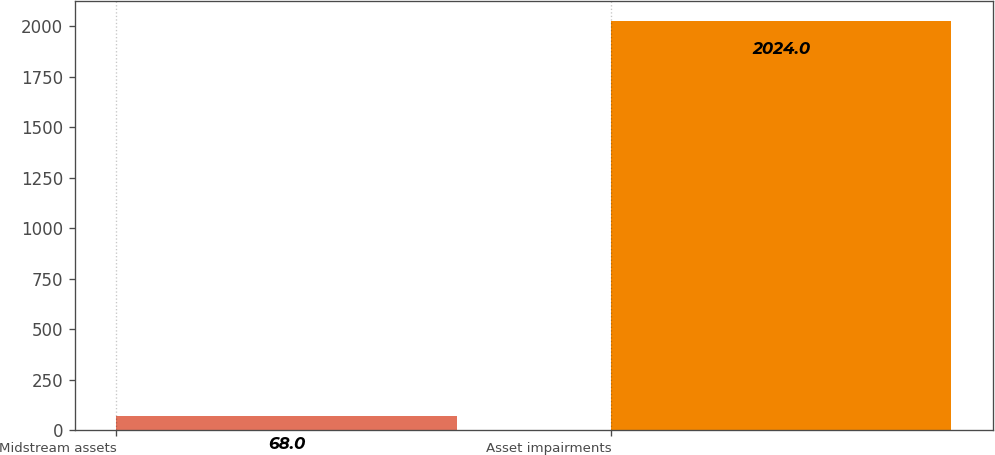<chart> <loc_0><loc_0><loc_500><loc_500><bar_chart><fcel>Midstream assets<fcel>Asset impairments<nl><fcel>68<fcel>2024<nl></chart> 